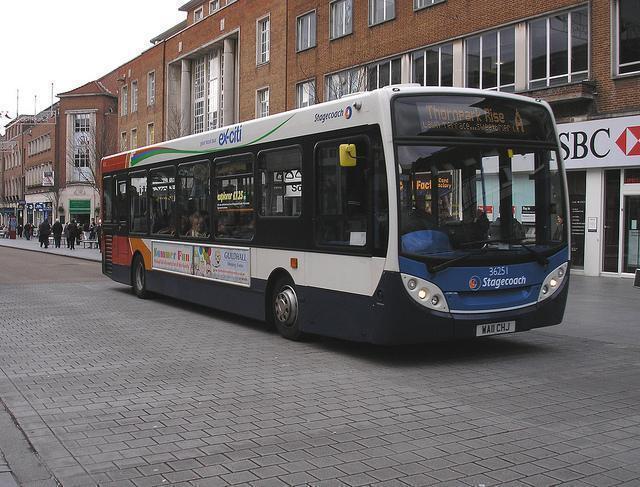What type street does this bus drive on?
Answer the question by selecting the correct answer among the 4 following choices.
Options: Brick, concrete, tar, dirt. Brick. 